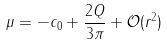<formula> <loc_0><loc_0><loc_500><loc_500>\mu = - c _ { 0 } + \frac { 2 Q } { 3 \pi } + \mathcal { O } ( r ^ { 2 } )</formula> 